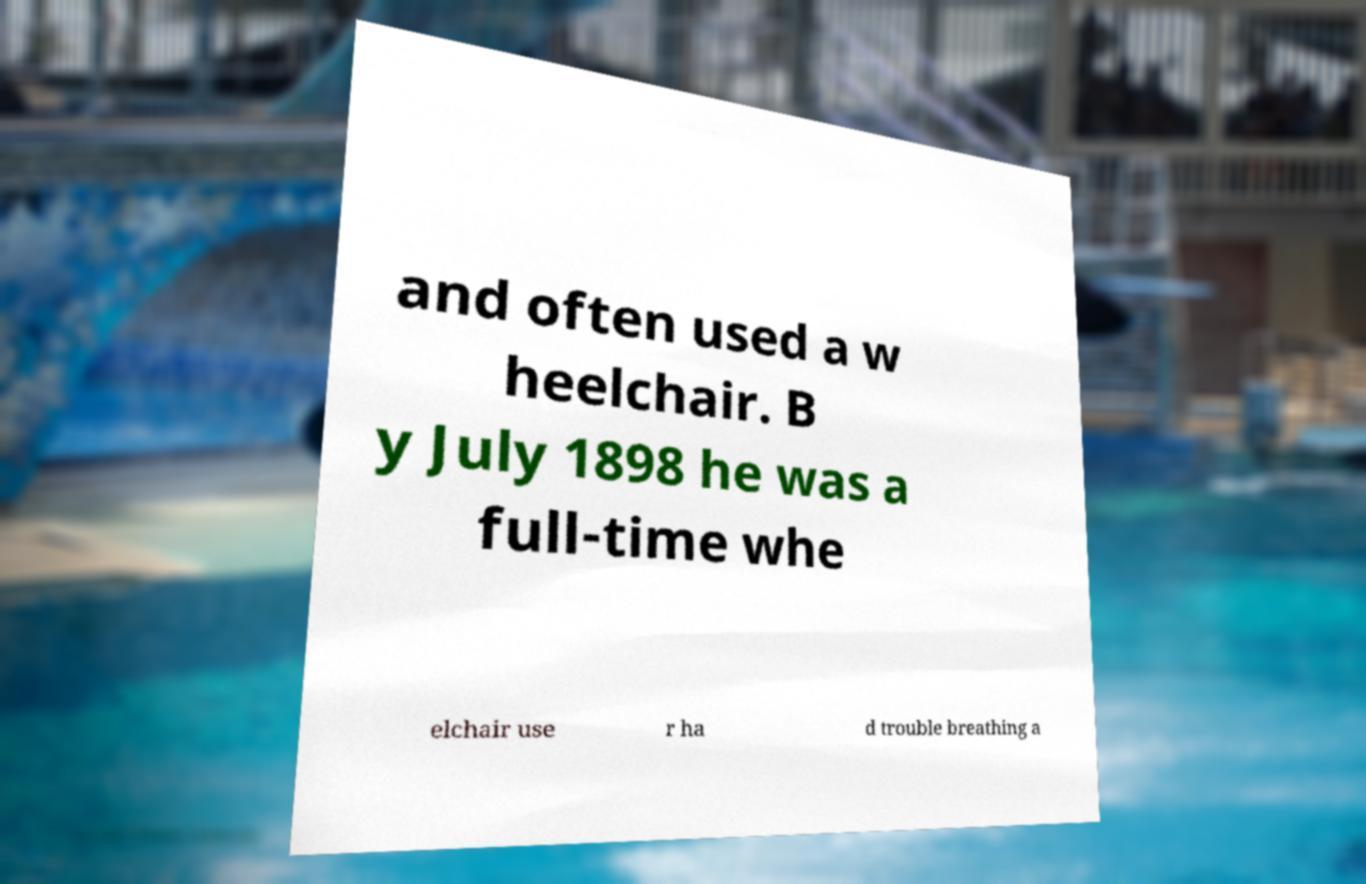Please identify and transcribe the text found in this image. and often used a w heelchair. B y July 1898 he was a full-time whe elchair use r ha d trouble breathing a 